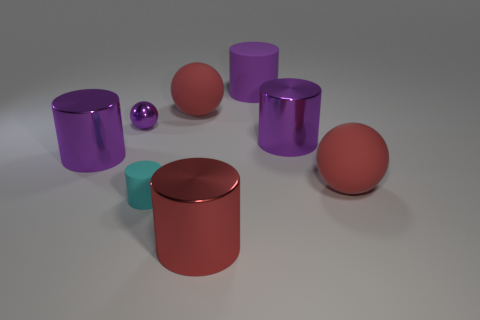There is a rubber thing that is the same color as the small metal thing; what is its size?
Provide a short and direct response. Large. Is the material of the cyan cylinder the same as the large purple cylinder left of the red cylinder?
Make the answer very short. No. Are there more purple balls that are in front of the small cyan matte cylinder than tiny matte cylinders?
Provide a succinct answer. No. There is a big rubber thing that is the same color as the small metal thing; what is its shape?
Your response must be concise. Cylinder. Is there a gray cylinder that has the same material as the red cylinder?
Your answer should be very brief. No. Do the tiny object behind the tiny matte thing and the big object that is on the left side of the cyan cylinder have the same material?
Offer a terse response. Yes. Is the number of big red metal cylinders behind the cyan rubber cylinder the same as the number of red shiny objects on the right side of the purple matte object?
Keep it short and to the point. Yes. What is the color of the other thing that is the same size as the cyan matte thing?
Provide a succinct answer. Purple. Are there any large shiny blocks that have the same color as the small cylinder?
Give a very brief answer. No. How many objects are either large purple metal cylinders left of the small cyan rubber object or large purple rubber things?
Your answer should be compact. 2. 